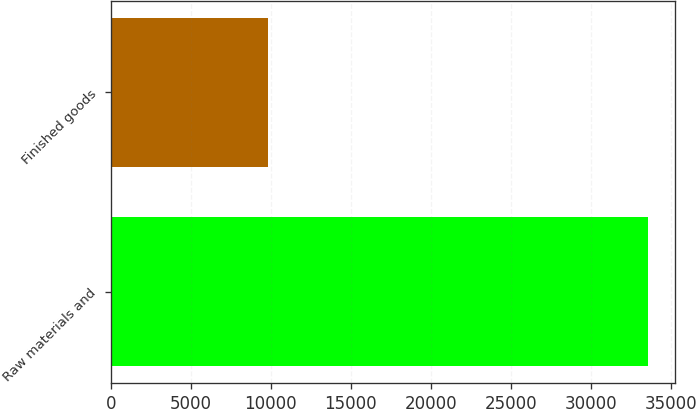<chart> <loc_0><loc_0><loc_500><loc_500><bar_chart><fcel>Raw materials and<fcel>Finished goods<nl><fcel>33596<fcel>9830<nl></chart> 